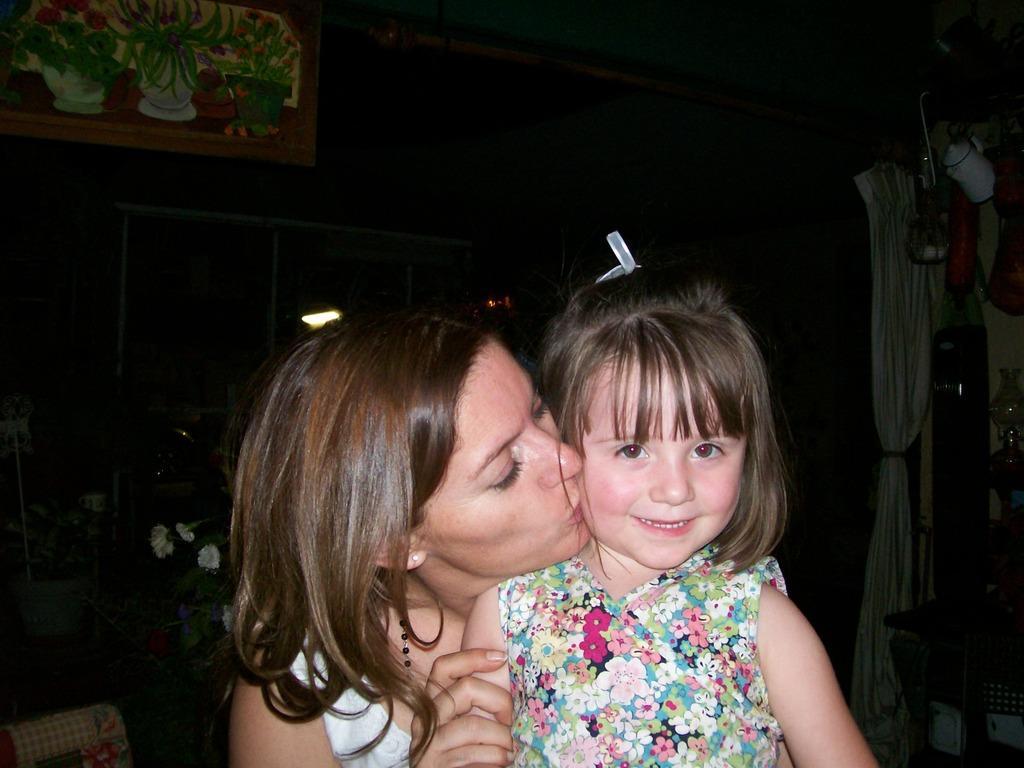Could you give a brief overview of what you see in this image? In this image I can see a woman and a girl. I can also see smile on the girl's face. In the background I can see a curtain, a table and few other stuffs. On the top left side of the image I can see a painting on the wall and I can also see few white colour things in the background. I can also see this image is little bit in dark. 